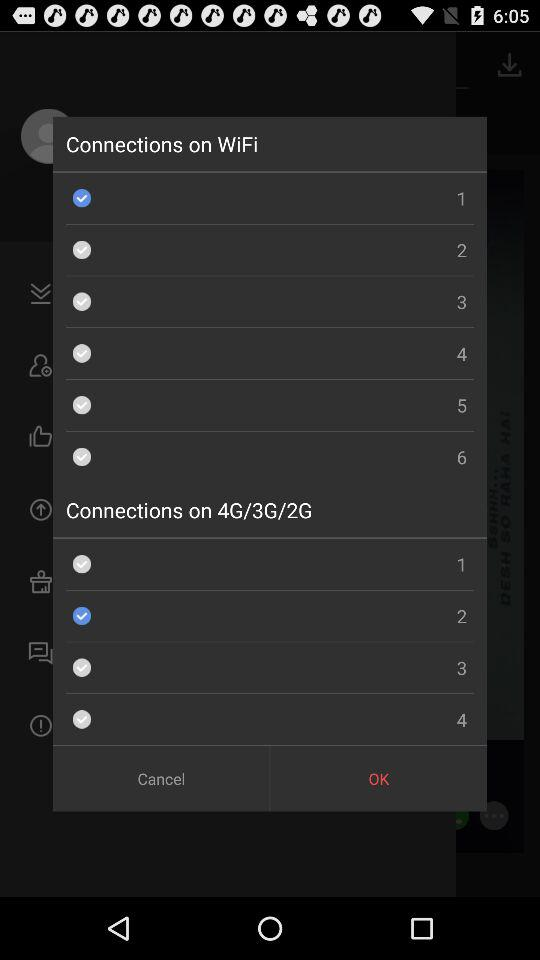Which option is selected for "Connections on 4G/3G/2G"? The selected option for "Connections on 4G/3G/2G" is "2". 